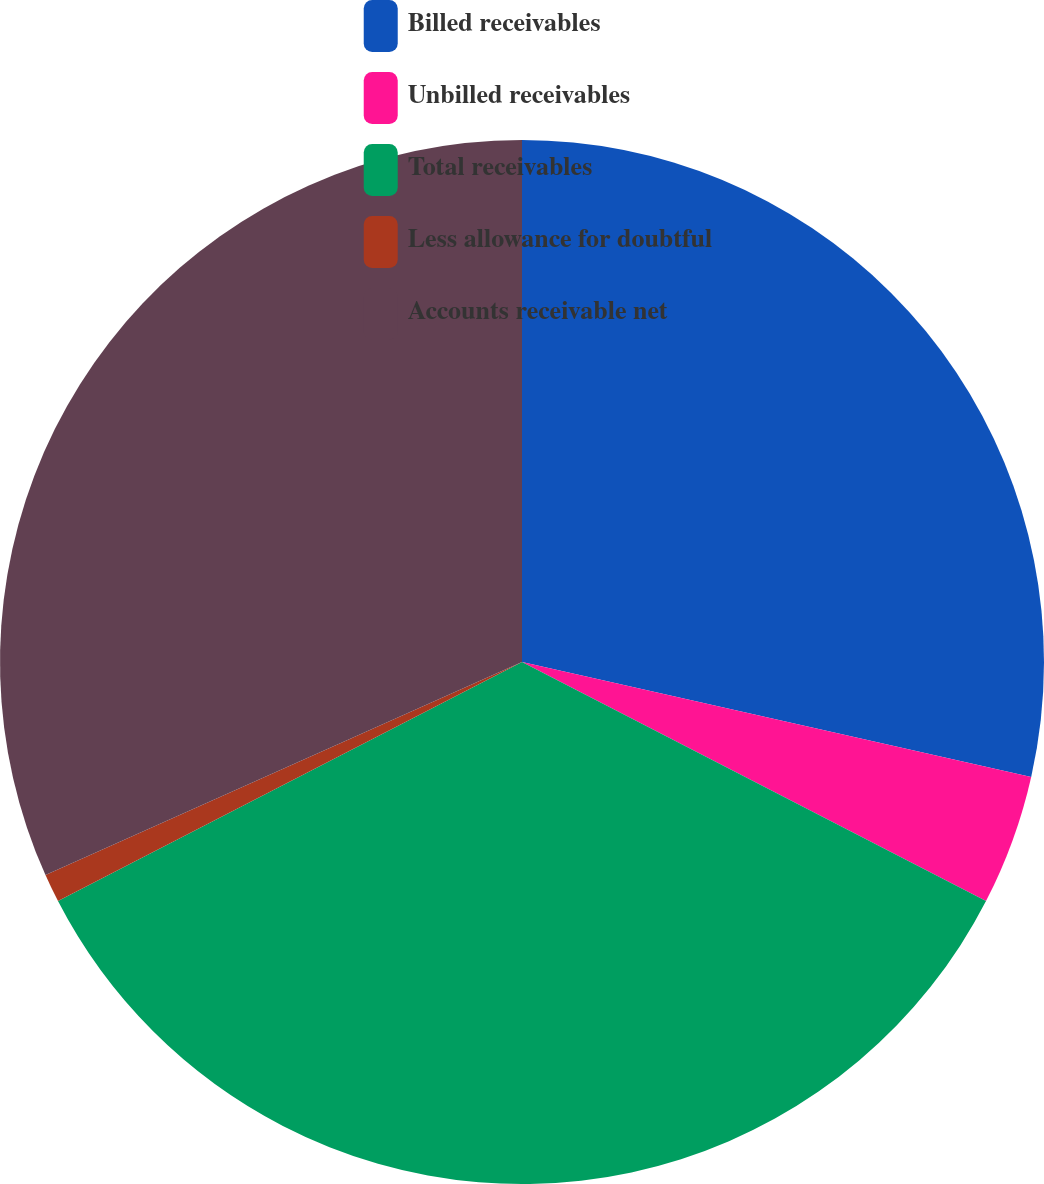Convert chart. <chart><loc_0><loc_0><loc_500><loc_500><pie_chart><fcel>Billed receivables<fcel>Unbilled receivables<fcel>Total receivables<fcel>Less allowance for doubtful<fcel>Accounts receivable net<nl><fcel>28.53%<fcel>4.04%<fcel>34.85%<fcel>0.88%<fcel>31.69%<nl></chart> 